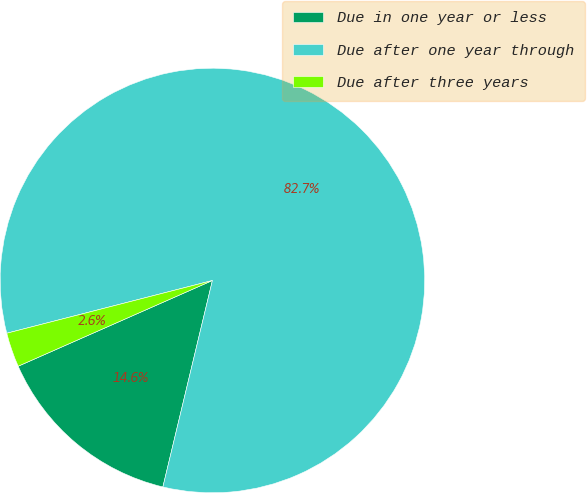Convert chart. <chart><loc_0><loc_0><loc_500><loc_500><pie_chart><fcel>Due in one year or less<fcel>Due after one year through<fcel>Due after three years<nl><fcel>14.64%<fcel>82.75%<fcel>2.62%<nl></chart> 